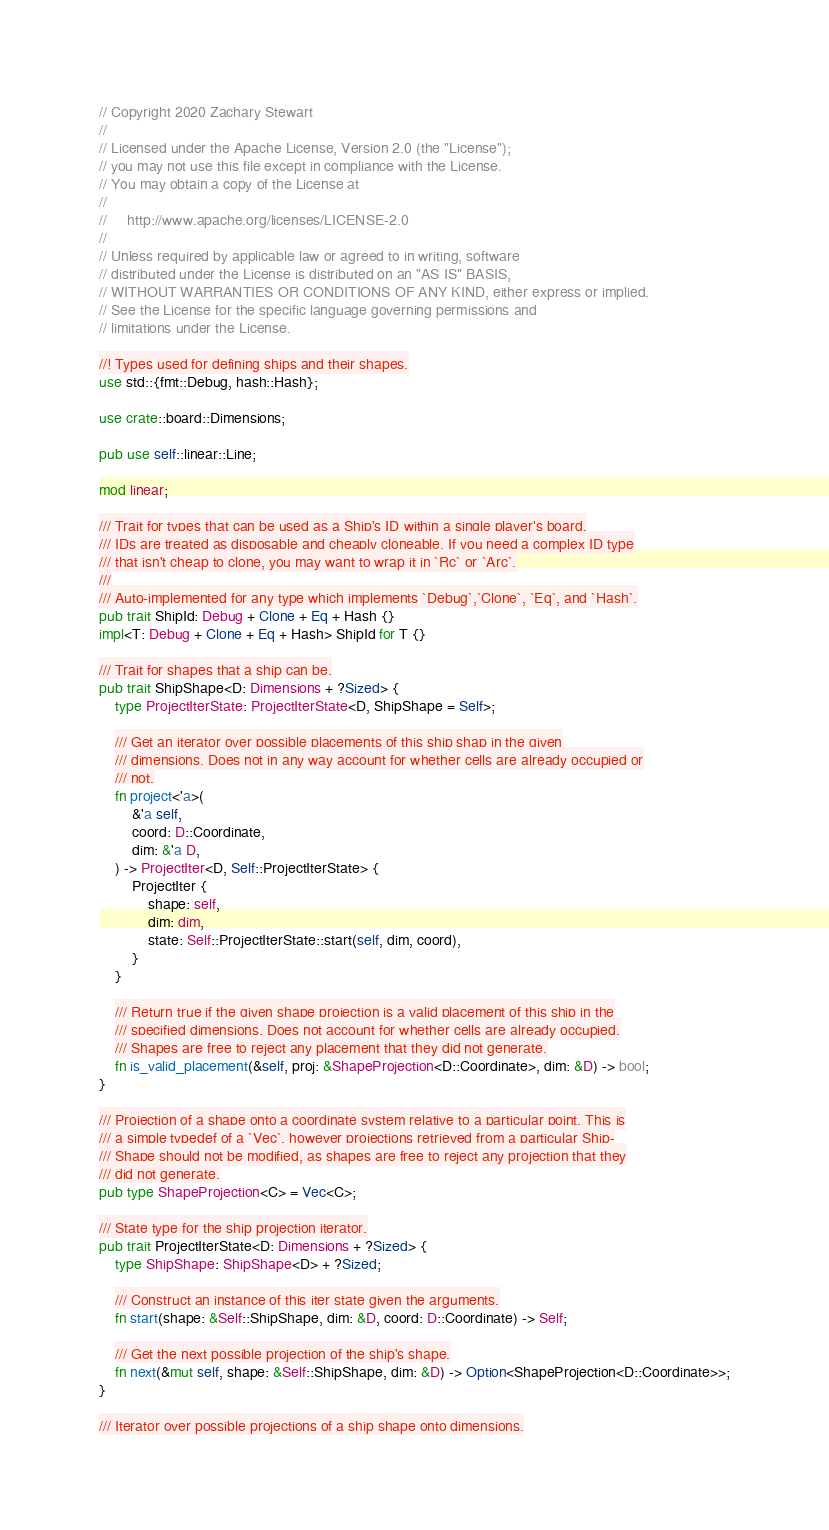<code> <loc_0><loc_0><loc_500><loc_500><_Rust_>// Copyright 2020 Zachary Stewart
//
// Licensed under the Apache License, Version 2.0 (the "License");
// you may not use this file except in compliance with the License.
// You may obtain a copy of the License at
//
//     http://www.apache.org/licenses/LICENSE-2.0
//
// Unless required by applicable law or agreed to in writing, software
// distributed under the License is distributed on an "AS IS" BASIS,
// WITHOUT WARRANTIES OR CONDITIONS OF ANY KIND, either express or implied.
// See the License for the specific language governing permissions and
// limitations under the License.

//! Types used for defining ships and their shapes.
use std::{fmt::Debug, hash::Hash};

use crate::board::Dimensions;

pub use self::linear::Line;

mod linear;

/// Trait for types that can be used as a Ship's ID within a single player's board.
/// IDs are treated as disposable and cheaply cloneable. If you need a complex ID type
/// that isn't cheap to clone, you may want to wrap it in `Rc` or `Arc`.
///
/// Auto-implemented for any type which implements `Debug`,`Clone`, `Eq`, and `Hash`.
pub trait ShipId: Debug + Clone + Eq + Hash {}
impl<T: Debug + Clone + Eq + Hash> ShipId for T {}

/// Trait for shapes that a ship can be.
pub trait ShipShape<D: Dimensions + ?Sized> {
    type ProjectIterState: ProjectIterState<D, ShipShape = Self>;

    /// Get an iterator over possible placements of this ship shap in the given
    /// dimensions. Does not in any way account for whether cells are already occupied or
    /// not.
    fn project<'a>(
        &'a self,
        coord: D::Coordinate,
        dim: &'a D,
    ) -> ProjectIter<D, Self::ProjectIterState> {
        ProjectIter {
            shape: self,
            dim: dim,
            state: Self::ProjectIterState::start(self, dim, coord),
        }
    }

    /// Return true if the given shape projection is a valid placement of this ship in the
    /// specified dimensions. Does not account for whether cells are already occupied.
    /// Shapes are free to reject any placement that they did not generate.
    fn is_valid_placement(&self, proj: &ShapeProjection<D::Coordinate>, dim: &D) -> bool;
}

/// Projection of a shape onto a coordinate system relative to a particular point. This is
/// a simple typedef of a `Vec`, however projections retrieved from a particular Ship-
/// Shape should not be modified, as shapes are free to reject any projection that they
/// did not generate.
pub type ShapeProjection<C> = Vec<C>;

/// State type for the ship projection iterator.
pub trait ProjectIterState<D: Dimensions + ?Sized> {
    type ShipShape: ShipShape<D> + ?Sized;

    /// Construct an instance of this iter state given the arguments.
    fn start(shape: &Self::ShipShape, dim: &D, coord: D::Coordinate) -> Self;

    /// Get the next possible projection of the ship's shape.
    fn next(&mut self, shape: &Self::ShipShape, dim: &D) -> Option<ShapeProjection<D::Coordinate>>;
}

/// Iterator over possible projections of a ship shape onto dimensions.</code> 